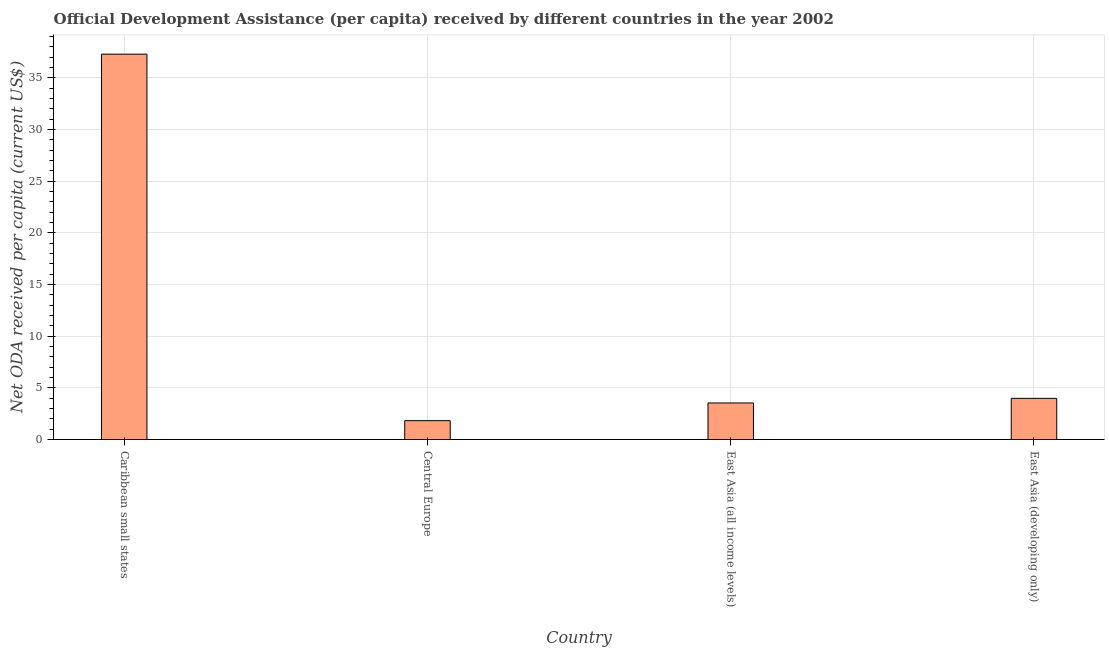Does the graph contain grids?
Your answer should be very brief. Yes. What is the title of the graph?
Offer a terse response. Official Development Assistance (per capita) received by different countries in the year 2002. What is the label or title of the X-axis?
Ensure brevity in your answer.  Country. What is the label or title of the Y-axis?
Ensure brevity in your answer.  Net ODA received per capita (current US$). What is the net oda received per capita in East Asia (all income levels)?
Give a very brief answer. 3.54. Across all countries, what is the maximum net oda received per capita?
Ensure brevity in your answer.  37.3. Across all countries, what is the minimum net oda received per capita?
Ensure brevity in your answer.  1.82. In which country was the net oda received per capita maximum?
Provide a succinct answer. Caribbean small states. In which country was the net oda received per capita minimum?
Keep it short and to the point. Central Europe. What is the sum of the net oda received per capita?
Your answer should be very brief. 46.65. What is the difference between the net oda received per capita in Caribbean small states and East Asia (all income levels)?
Your response must be concise. 33.76. What is the average net oda received per capita per country?
Your answer should be very brief. 11.66. What is the median net oda received per capita?
Your response must be concise. 3.76. What is the ratio of the net oda received per capita in Caribbean small states to that in East Asia (developing only)?
Provide a short and direct response. 9.36. Is the net oda received per capita in Caribbean small states less than that in Central Europe?
Provide a short and direct response. No. What is the difference between the highest and the second highest net oda received per capita?
Give a very brief answer. 33.32. Is the sum of the net oda received per capita in East Asia (all income levels) and East Asia (developing only) greater than the maximum net oda received per capita across all countries?
Your response must be concise. No. What is the difference between the highest and the lowest net oda received per capita?
Your answer should be very brief. 35.48. How many bars are there?
Your answer should be very brief. 4. Are all the bars in the graph horizontal?
Offer a very short reply. No. How many countries are there in the graph?
Offer a terse response. 4. What is the difference between two consecutive major ticks on the Y-axis?
Ensure brevity in your answer.  5. What is the Net ODA received per capita (current US$) of Caribbean small states?
Your response must be concise. 37.3. What is the Net ODA received per capita (current US$) in Central Europe?
Make the answer very short. 1.82. What is the Net ODA received per capita (current US$) in East Asia (all income levels)?
Make the answer very short. 3.54. What is the Net ODA received per capita (current US$) in East Asia (developing only)?
Provide a succinct answer. 3.98. What is the difference between the Net ODA received per capita (current US$) in Caribbean small states and Central Europe?
Provide a short and direct response. 35.48. What is the difference between the Net ODA received per capita (current US$) in Caribbean small states and East Asia (all income levels)?
Your answer should be very brief. 33.76. What is the difference between the Net ODA received per capita (current US$) in Caribbean small states and East Asia (developing only)?
Give a very brief answer. 33.32. What is the difference between the Net ODA received per capita (current US$) in Central Europe and East Asia (all income levels)?
Your response must be concise. -1.71. What is the difference between the Net ODA received per capita (current US$) in Central Europe and East Asia (developing only)?
Your answer should be compact. -2.16. What is the difference between the Net ODA received per capita (current US$) in East Asia (all income levels) and East Asia (developing only)?
Offer a very short reply. -0.45. What is the ratio of the Net ODA received per capita (current US$) in Caribbean small states to that in Central Europe?
Keep it short and to the point. 20.44. What is the ratio of the Net ODA received per capita (current US$) in Caribbean small states to that in East Asia (all income levels)?
Provide a succinct answer. 10.54. What is the ratio of the Net ODA received per capita (current US$) in Caribbean small states to that in East Asia (developing only)?
Ensure brevity in your answer.  9.36. What is the ratio of the Net ODA received per capita (current US$) in Central Europe to that in East Asia (all income levels)?
Ensure brevity in your answer.  0.52. What is the ratio of the Net ODA received per capita (current US$) in Central Europe to that in East Asia (developing only)?
Ensure brevity in your answer.  0.46. What is the ratio of the Net ODA received per capita (current US$) in East Asia (all income levels) to that in East Asia (developing only)?
Offer a very short reply. 0.89. 